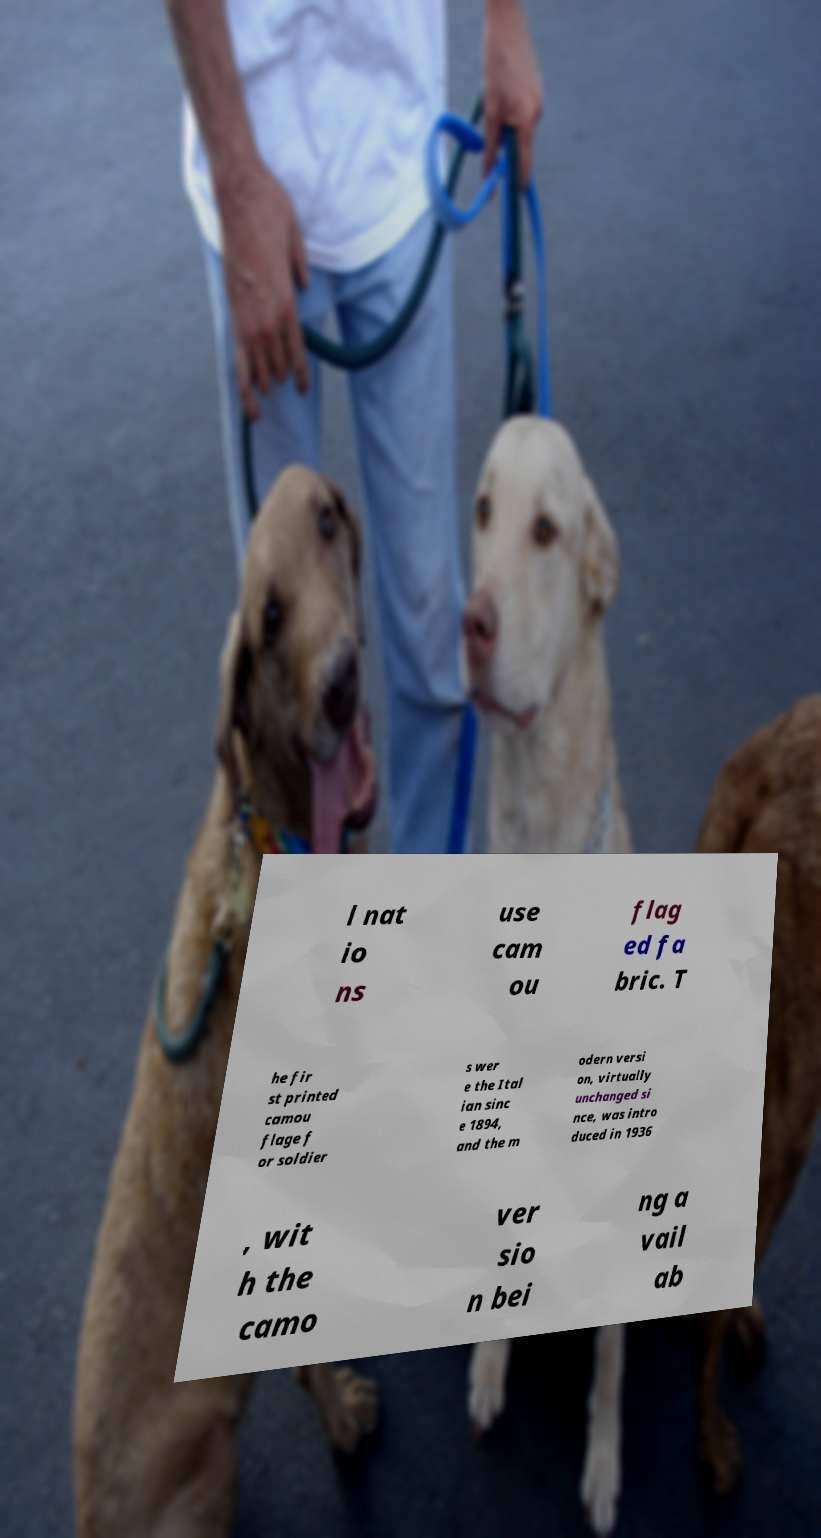Could you assist in decoding the text presented in this image and type it out clearly? l nat io ns use cam ou flag ed fa bric. T he fir st printed camou flage f or soldier s wer e the Ital ian sinc e 1894, and the m odern versi on, virtually unchanged si nce, was intro duced in 1936 , wit h the camo ver sio n bei ng a vail ab 